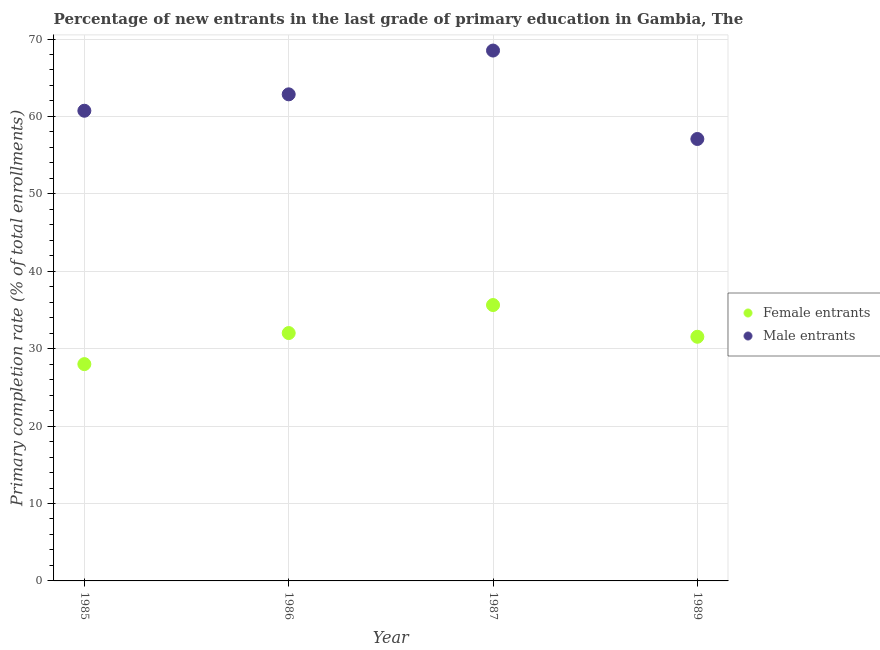How many different coloured dotlines are there?
Offer a terse response. 2. Is the number of dotlines equal to the number of legend labels?
Your answer should be very brief. Yes. What is the primary completion rate of male entrants in 1987?
Your answer should be compact. 68.51. Across all years, what is the maximum primary completion rate of female entrants?
Keep it short and to the point. 35.64. Across all years, what is the minimum primary completion rate of female entrants?
Your response must be concise. 28.01. In which year was the primary completion rate of male entrants maximum?
Your answer should be very brief. 1987. What is the total primary completion rate of female entrants in the graph?
Your answer should be very brief. 127.2. What is the difference between the primary completion rate of female entrants in 1986 and that in 1987?
Offer a terse response. -3.62. What is the difference between the primary completion rate of female entrants in 1989 and the primary completion rate of male entrants in 1986?
Provide a succinct answer. -31.31. What is the average primary completion rate of male entrants per year?
Your answer should be compact. 62.3. In the year 1986, what is the difference between the primary completion rate of male entrants and primary completion rate of female entrants?
Your answer should be very brief. 30.83. What is the ratio of the primary completion rate of female entrants in 1986 to that in 1989?
Keep it short and to the point. 1.02. Is the primary completion rate of male entrants in 1985 less than that in 1987?
Keep it short and to the point. Yes. Is the difference between the primary completion rate of male entrants in 1985 and 1987 greater than the difference between the primary completion rate of female entrants in 1985 and 1987?
Your response must be concise. No. What is the difference between the highest and the second highest primary completion rate of female entrants?
Your answer should be very brief. 3.62. What is the difference between the highest and the lowest primary completion rate of male entrants?
Make the answer very short. 11.42. In how many years, is the primary completion rate of male entrants greater than the average primary completion rate of male entrants taken over all years?
Your answer should be very brief. 2. Is the primary completion rate of male entrants strictly less than the primary completion rate of female entrants over the years?
Your answer should be very brief. No. Does the graph contain any zero values?
Keep it short and to the point. No. Does the graph contain grids?
Your answer should be compact. Yes. Where does the legend appear in the graph?
Your response must be concise. Center right. How many legend labels are there?
Ensure brevity in your answer.  2. What is the title of the graph?
Your answer should be compact. Percentage of new entrants in the last grade of primary education in Gambia, The. Does "% of GNI" appear as one of the legend labels in the graph?
Your answer should be very brief. No. What is the label or title of the X-axis?
Your answer should be compact. Year. What is the label or title of the Y-axis?
Offer a terse response. Primary completion rate (% of total enrollments). What is the Primary completion rate (% of total enrollments) in Female entrants in 1985?
Make the answer very short. 28.01. What is the Primary completion rate (% of total enrollments) in Male entrants in 1985?
Give a very brief answer. 60.73. What is the Primary completion rate (% of total enrollments) of Female entrants in 1986?
Offer a very short reply. 32.02. What is the Primary completion rate (% of total enrollments) in Male entrants in 1986?
Provide a short and direct response. 62.85. What is the Primary completion rate (% of total enrollments) of Female entrants in 1987?
Provide a succinct answer. 35.64. What is the Primary completion rate (% of total enrollments) of Male entrants in 1987?
Your answer should be compact. 68.51. What is the Primary completion rate (% of total enrollments) of Female entrants in 1989?
Your answer should be compact. 31.54. What is the Primary completion rate (% of total enrollments) of Male entrants in 1989?
Offer a terse response. 57.09. Across all years, what is the maximum Primary completion rate (% of total enrollments) of Female entrants?
Provide a short and direct response. 35.64. Across all years, what is the maximum Primary completion rate (% of total enrollments) of Male entrants?
Offer a terse response. 68.51. Across all years, what is the minimum Primary completion rate (% of total enrollments) in Female entrants?
Ensure brevity in your answer.  28.01. Across all years, what is the minimum Primary completion rate (% of total enrollments) of Male entrants?
Offer a very short reply. 57.09. What is the total Primary completion rate (% of total enrollments) of Female entrants in the graph?
Give a very brief answer. 127.2. What is the total Primary completion rate (% of total enrollments) in Male entrants in the graph?
Offer a very short reply. 249.18. What is the difference between the Primary completion rate (% of total enrollments) of Female entrants in 1985 and that in 1986?
Provide a succinct answer. -4.01. What is the difference between the Primary completion rate (% of total enrollments) of Male entrants in 1985 and that in 1986?
Ensure brevity in your answer.  -2.12. What is the difference between the Primary completion rate (% of total enrollments) in Female entrants in 1985 and that in 1987?
Ensure brevity in your answer.  -7.63. What is the difference between the Primary completion rate (% of total enrollments) in Male entrants in 1985 and that in 1987?
Provide a short and direct response. -7.77. What is the difference between the Primary completion rate (% of total enrollments) in Female entrants in 1985 and that in 1989?
Make the answer very short. -3.53. What is the difference between the Primary completion rate (% of total enrollments) in Male entrants in 1985 and that in 1989?
Your answer should be very brief. 3.65. What is the difference between the Primary completion rate (% of total enrollments) of Female entrants in 1986 and that in 1987?
Offer a very short reply. -3.62. What is the difference between the Primary completion rate (% of total enrollments) of Male entrants in 1986 and that in 1987?
Make the answer very short. -5.66. What is the difference between the Primary completion rate (% of total enrollments) in Female entrants in 1986 and that in 1989?
Ensure brevity in your answer.  0.48. What is the difference between the Primary completion rate (% of total enrollments) of Male entrants in 1986 and that in 1989?
Give a very brief answer. 5.77. What is the difference between the Primary completion rate (% of total enrollments) in Female entrants in 1987 and that in 1989?
Ensure brevity in your answer.  4.1. What is the difference between the Primary completion rate (% of total enrollments) in Male entrants in 1987 and that in 1989?
Offer a terse response. 11.42. What is the difference between the Primary completion rate (% of total enrollments) of Female entrants in 1985 and the Primary completion rate (% of total enrollments) of Male entrants in 1986?
Offer a terse response. -34.85. What is the difference between the Primary completion rate (% of total enrollments) in Female entrants in 1985 and the Primary completion rate (% of total enrollments) in Male entrants in 1987?
Your answer should be very brief. -40.5. What is the difference between the Primary completion rate (% of total enrollments) of Female entrants in 1985 and the Primary completion rate (% of total enrollments) of Male entrants in 1989?
Your answer should be very brief. -29.08. What is the difference between the Primary completion rate (% of total enrollments) of Female entrants in 1986 and the Primary completion rate (% of total enrollments) of Male entrants in 1987?
Keep it short and to the point. -36.49. What is the difference between the Primary completion rate (% of total enrollments) in Female entrants in 1986 and the Primary completion rate (% of total enrollments) in Male entrants in 1989?
Offer a very short reply. -25.07. What is the difference between the Primary completion rate (% of total enrollments) of Female entrants in 1987 and the Primary completion rate (% of total enrollments) of Male entrants in 1989?
Offer a very short reply. -21.45. What is the average Primary completion rate (% of total enrollments) of Female entrants per year?
Keep it short and to the point. 31.8. What is the average Primary completion rate (% of total enrollments) in Male entrants per year?
Make the answer very short. 62.3. In the year 1985, what is the difference between the Primary completion rate (% of total enrollments) of Female entrants and Primary completion rate (% of total enrollments) of Male entrants?
Provide a short and direct response. -32.73. In the year 1986, what is the difference between the Primary completion rate (% of total enrollments) of Female entrants and Primary completion rate (% of total enrollments) of Male entrants?
Keep it short and to the point. -30.83. In the year 1987, what is the difference between the Primary completion rate (% of total enrollments) of Female entrants and Primary completion rate (% of total enrollments) of Male entrants?
Your response must be concise. -32.87. In the year 1989, what is the difference between the Primary completion rate (% of total enrollments) in Female entrants and Primary completion rate (% of total enrollments) in Male entrants?
Make the answer very short. -25.55. What is the ratio of the Primary completion rate (% of total enrollments) of Female entrants in 1985 to that in 1986?
Give a very brief answer. 0.87. What is the ratio of the Primary completion rate (% of total enrollments) of Male entrants in 1985 to that in 1986?
Ensure brevity in your answer.  0.97. What is the ratio of the Primary completion rate (% of total enrollments) of Female entrants in 1985 to that in 1987?
Your answer should be compact. 0.79. What is the ratio of the Primary completion rate (% of total enrollments) in Male entrants in 1985 to that in 1987?
Keep it short and to the point. 0.89. What is the ratio of the Primary completion rate (% of total enrollments) of Female entrants in 1985 to that in 1989?
Give a very brief answer. 0.89. What is the ratio of the Primary completion rate (% of total enrollments) in Male entrants in 1985 to that in 1989?
Offer a very short reply. 1.06. What is the ratio of the Primary completion rate (% of total enrollments) of Female entrants in 1986 to that in 1987?
Provide a succinct answer. 0.9. What is the ratio of the Primary completion rate (% of total enrollments) of Male entrants in 1986 to that in 1987?
Offer a very short reply. 0.92. What is the ratio of the Primary completion rate (% of total enrollments) of Female entrants in 1986 to that in 1989?
Your answer should be very brief. 1.02. What is the ratio of the Primary completion rate (% of total enrollments) of Male entrants in 1986 to that in 1989?
Give a very brief answer. 1.1. What is the ratio of the Primary completion rate (% of total enrollments) in Female entrants in 1987 to that in 1989?
Provide a short and direct response. 1.13. What is the ratio of the Primary completion rate (% of total enrollments) in Male entrants in 1987 to that in 1989?
Ensure brevity in your answer.  1.2. What is the difference between the highest and the second highest Primary completion rate (% of total enrollments) in Female entrants?
Offer a terse response. 3.62. What is the difference between the highest and the second highest Primary completion rate (% of total enrollments) of Male entrants?
Offer a terse response. 5.66. What is the difference between the highest and the lowest Primary completion rate (% of total enrollments) of Female entrants?
Your response must be concise. 7.63. What is the difference between the highest and the lowest Primary completion rate (% of total enrollments) of Male entrants?
Ensure brevity in your answer.  11.42. 